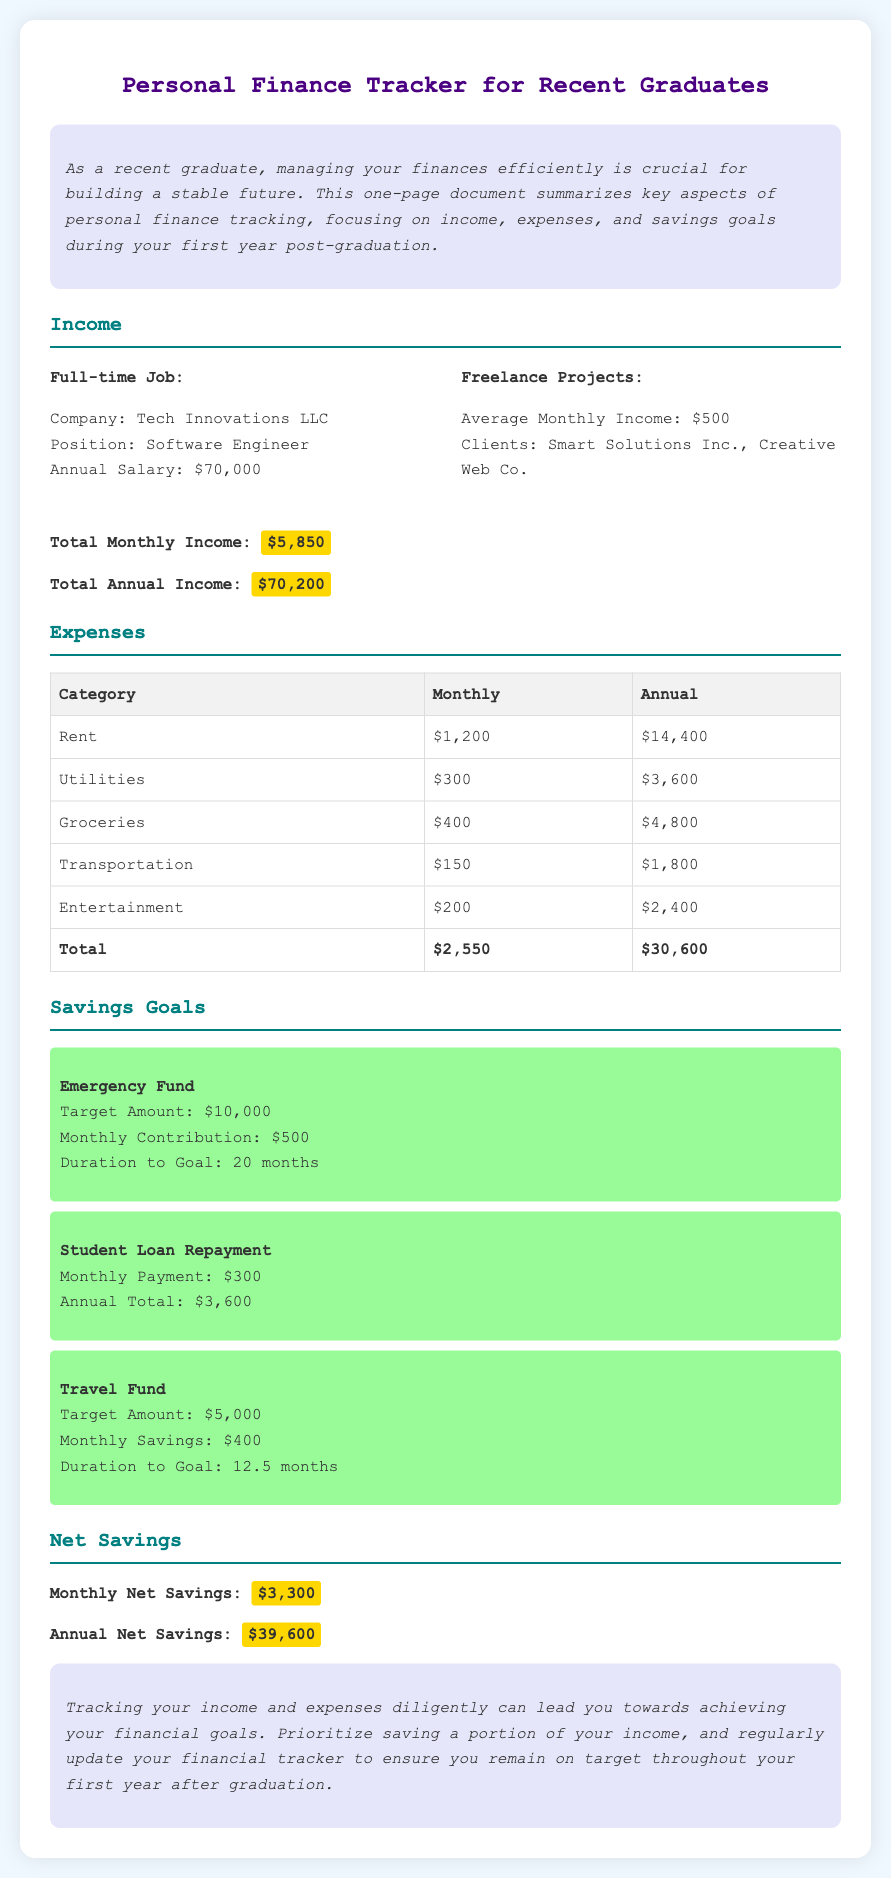What is the annual salary from the full-time job? The document states the annual salary from the full-time job as $70,000.
Answer: $70,000 How much is the average monthly income from freelance projects? The document indicates the average monthly income from freelance projects is $500.
Answer: $500 What is the total monthly income? The total monthly income is computed as $70,000 annual salary divided by 12 plus $500 from freelance projects, which totals $5,850.
Answer: $5,850 What is the total annual expense? The document provides the total annual expenses, which add up to $30,600.
Answer: $30,600 How much is the monthly contribution to the emergency fund? According to the document, the monthly contribution to the emergency fund is $500.
Answer: $500 What is the target amount for the travel fund? The target amount for the travel fund, as stated in the document, is $5,000.
Answer: $5,000 What is the monthly net savings? The document mentions the monthly net savings, which is calculated as total monthly income minus total monthly expenses, totaling $3,300.
Answer: $3,300 How long will it take to reach the emergency fund goal? The document states that it will take 20 months to reach the emergency fund goal.
Answer: 20 months What is the annual total for student loan repayment? The document states that the annual total for student loan repayment is $3,600.
Answer: $3,600 